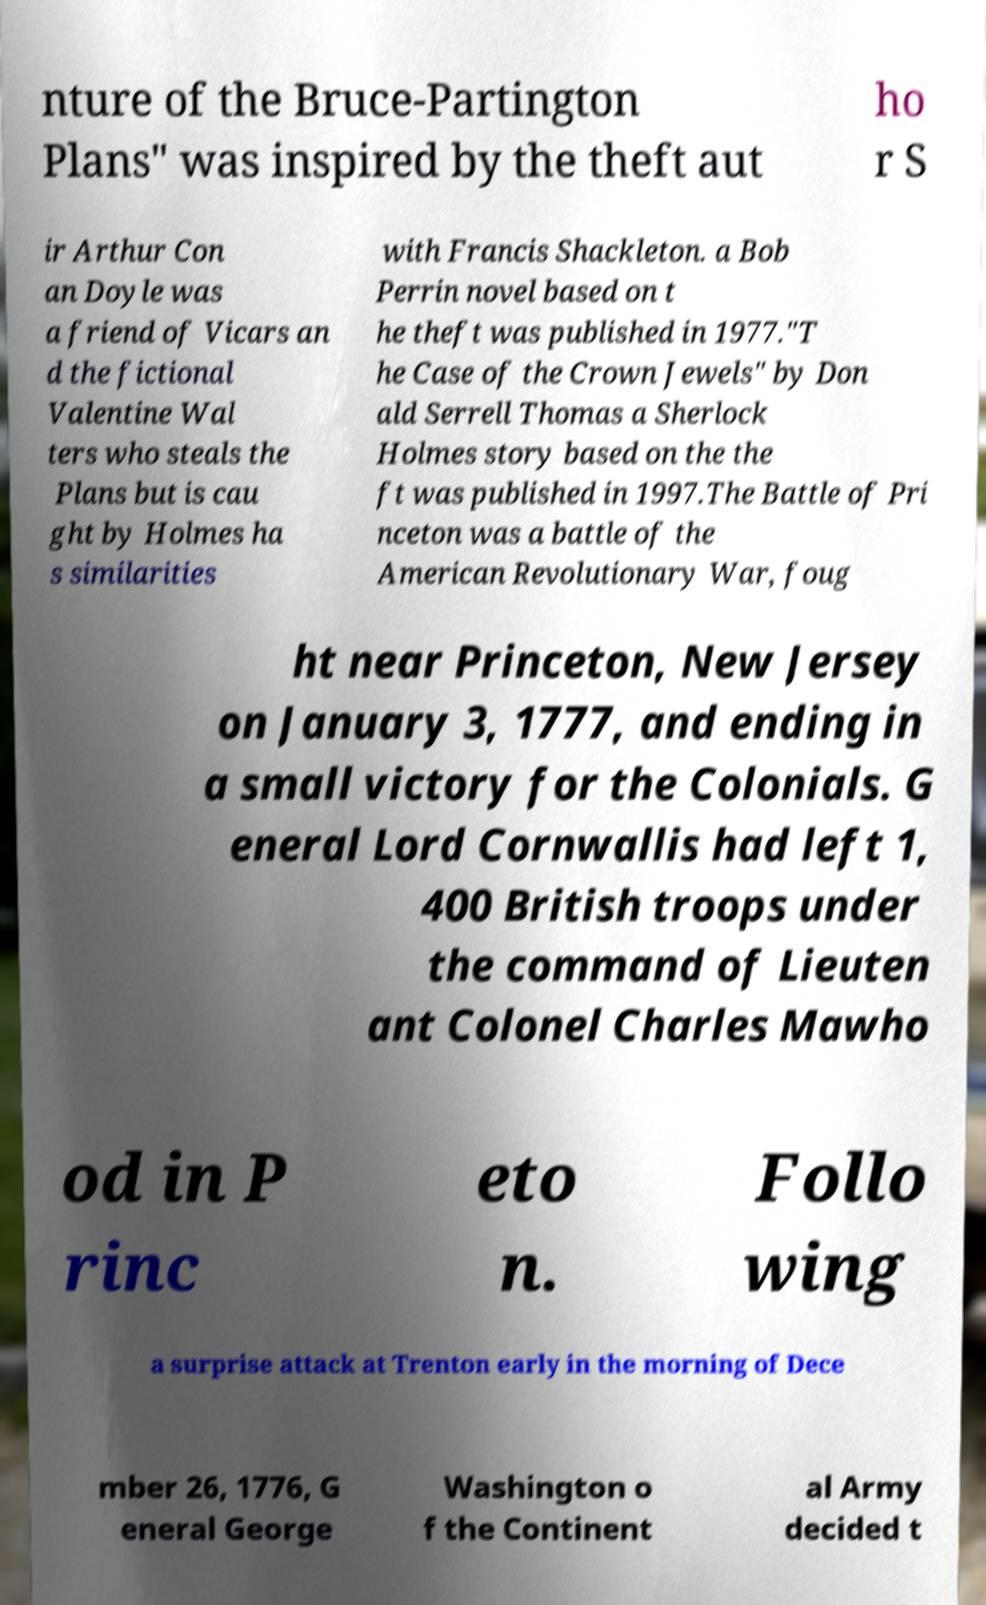Can you read and provide the text displayed in the image?This photo seems to have some interesting text. Can you extract and type it out for me? nture of the Bruce-Partington Plans" was inspired by the theft aut ho r S ir Arthur Con an Doyle was a friend of Vicars an d the fictional Valentine Wal ters who steals the Plans but is cau ght by Holmes ha s similarities with Francis Shackleton. a Bob Perrin novel based on t he theft was published in 1977."T he Case of the Crown Jewels" by Don ald Serrell Thomas a Sherlock Holmes story based on the the ft was published in 1997.The Battle of Pri nceton was a battle of the American Revolutionary War, foug ht near Princeton, New Jersey on January 3, 1777, and ending in a small victory for the Colonials. G eneral Lord Cornwallis had left 1, 400 British troops under the command of Lieuten ant Colonel Charles Mawho od in P rinc eto n. Follo wing a surprise attack at Trenton early in the morning of Dece mber 26, 1776, G eneral George Washington o f the Continent al Army decided t 